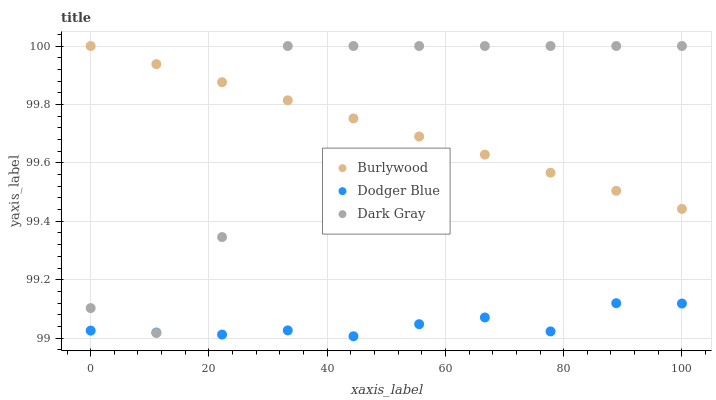Does Dodger Blue have the minimum area under the curve?
Answer yes or no. Yes. Does Dark Gray have the maximum area under the curve?
Answer yes or no. Yes. Does Dark Gray have the minimum area under the curve?
Answer yes or no. No. Does Dodger Blue have the maximum area under the curve?
Answer yes or no. No. Is Burlywood the smoothest?
Answer yes or no. Yes. Is Dark Gray the roughest?
Answer yes or no. Yes. Is Dodger Blue the smoothest?
Answer yes or no. No. Is Dodger Blue the roughest?
Answer yes or no. No. Does Dodger Blue have the lowest value?
Answer yes or no. Yes. Does Dark Gray have the lowest value?
Answer yes or no. No. Does Dark Gray have the highest value?
Answer yes or no. Yes. Does Dodger Blue have the highest value?
Answer yes or no. No. Is Dodger Blue less than Burlywood?
Answer yes or no. Yes. Is Burlywood greater than Dodger Blue?
Answer yes or no. Yes. Does Dark Gray intersect Dodger Blue?
Answer yes or no. Yes. Is Dark Gray less than Dodger Blue?
Answer yes or no. No. Is Dark Gray greater than Dodger Blue?
Answer yes or no. No. Does Dodger Blue intersect Burlywood?
Answer yes or no. No. 